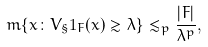<formula> <loc_0><loc_0><loc_500><loc_500>m \{ x \colon V _ { \S } 1 _ { F } ( x ) \gtrsim \lambda \} \lesssim _ { p } \frac { | F | } { \lambda ^ { p } } ,</formula> 